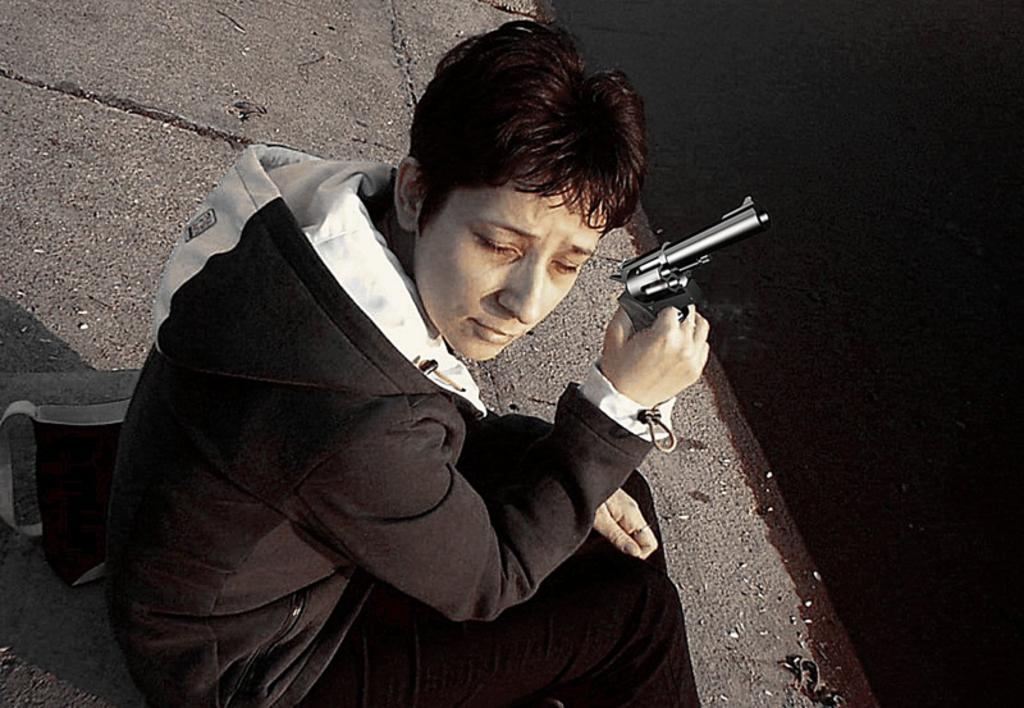What is the person in the image holding? The person is holding a gun in the image. What else can be seen in the image besides the person and the gun? There is a bag in the image. What is visible on the right side of the image? Water is visible on the right side of the image. What type of jeans is the person wearing in the image? There is no information about the person's clothing in the image, so we cannot determine if they are wearing jeans or any other type of clothing. 